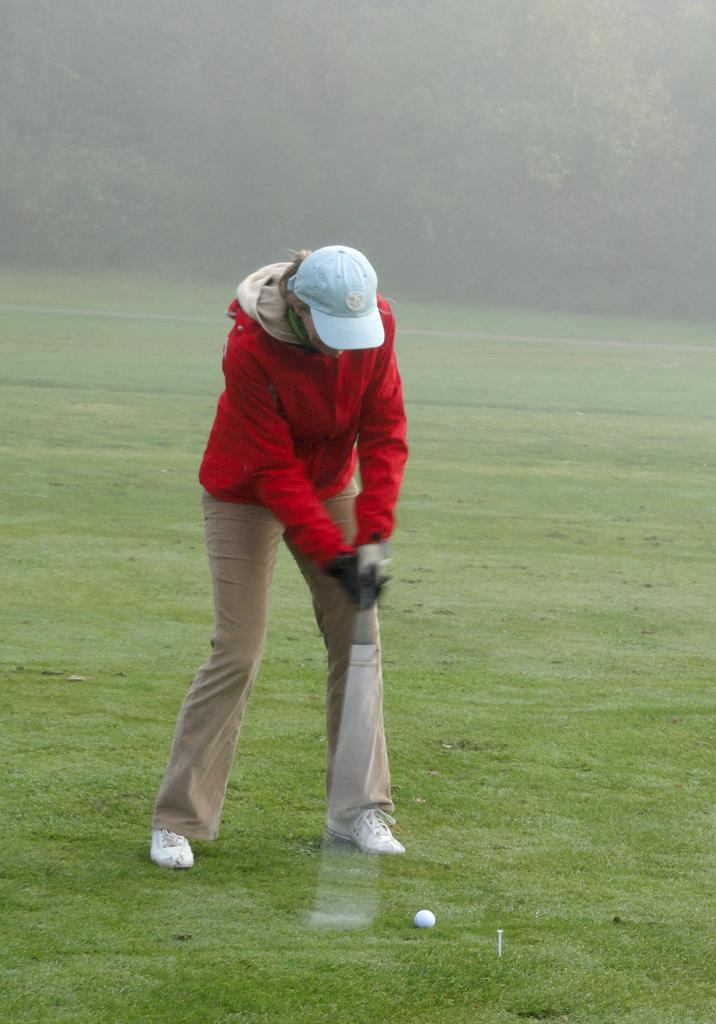What is the person in the image doing? The person is standing on the grass in the image. What object can be seen near the person? There is a golf ball in the image. What type of vegetation is present in the image? There are trees in the image. What atmospheric condition is visible in the image? There is fog visible in the image. What type of drum can be heard playing in harmony with the person in the image? There is no drum or music present in the image; it only features a person standing on the grass, a golf ball, trees, and fog. 